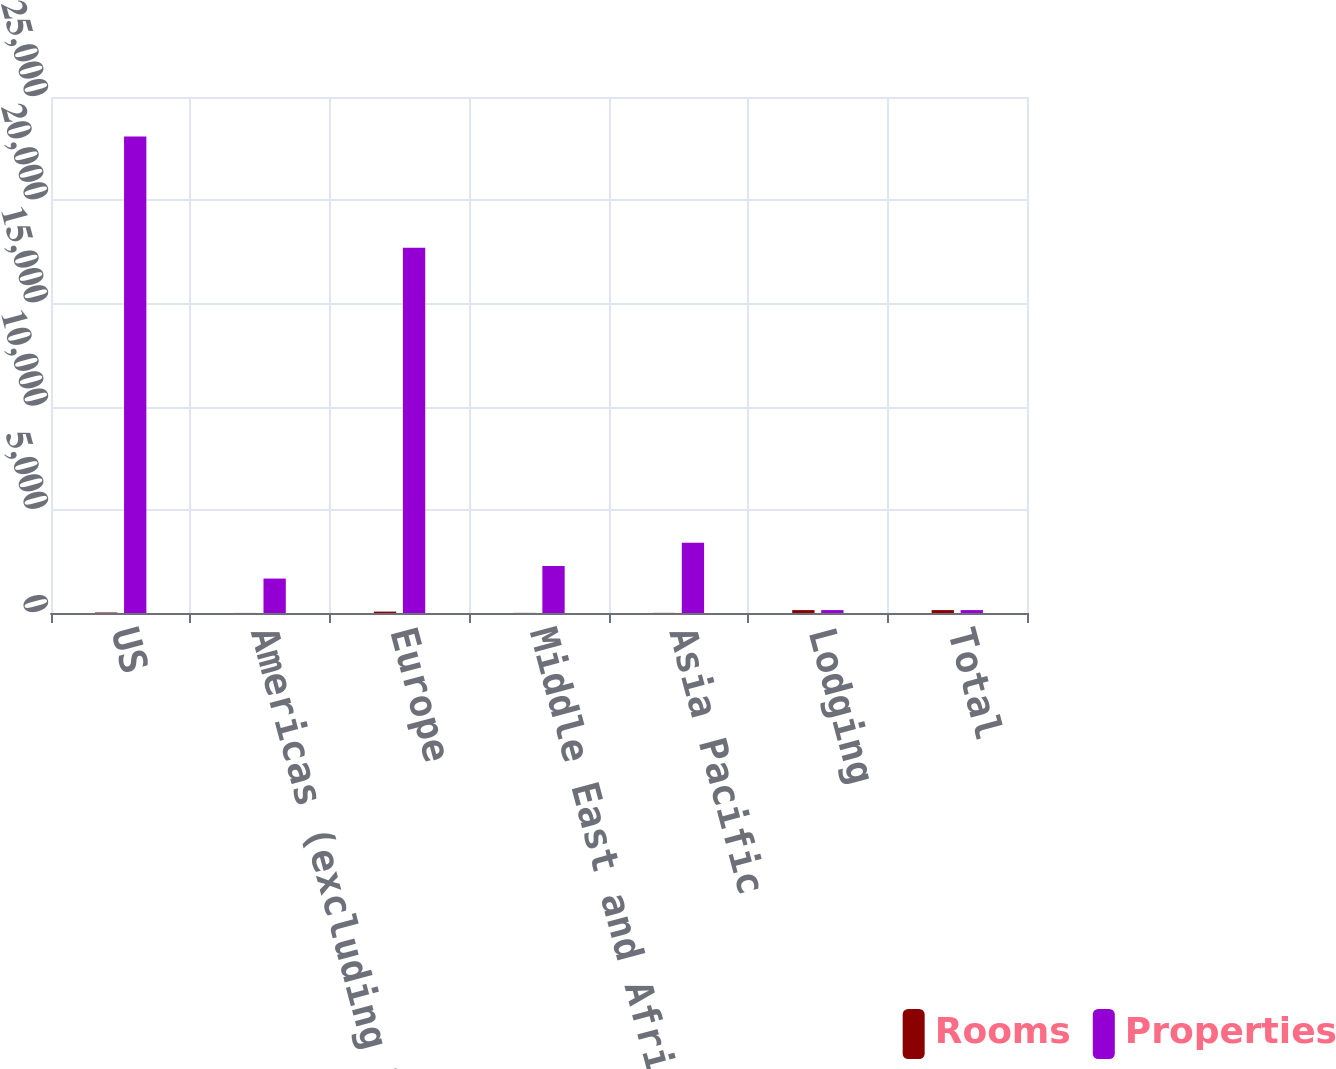<chart> <loc_0><loc_0><loc_500><loc_500><stacked_bar_chart><ecel><fcel>US<fcel>Americas (excluding US)<fcel>Europe<fcel>Middle East and Africa<fcel>Asia Pacific<fcel>Lodging<fcel>Total<nl><fcel>Rooms<fcel>25<fcel>3<fcel>68<fcel>6<fcel>7<fcel>141<fcel>141<nl><fcel>Properties<fcel>23089<fcel>1668<fcel>17695<fcel>2279<fcel>3403<fcel>141<fcel>141<nl></chart> 